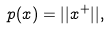<formula> <loc_0><loc_0><loc_500><loc_500>p ( x ) = | | x ^ { + } | | ,</formula> 